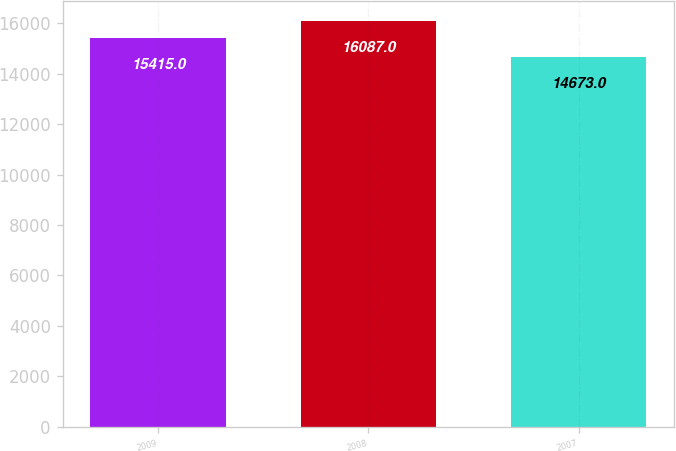Convert chart to OTSL. <chart><loc_0><loc_0><loc_500><loc_500><bar_chart><fcel>2009<fcel>2008<fcel>2007<nl><fcel>15415<fcel>16087<fcel>14673<nl></chart> 